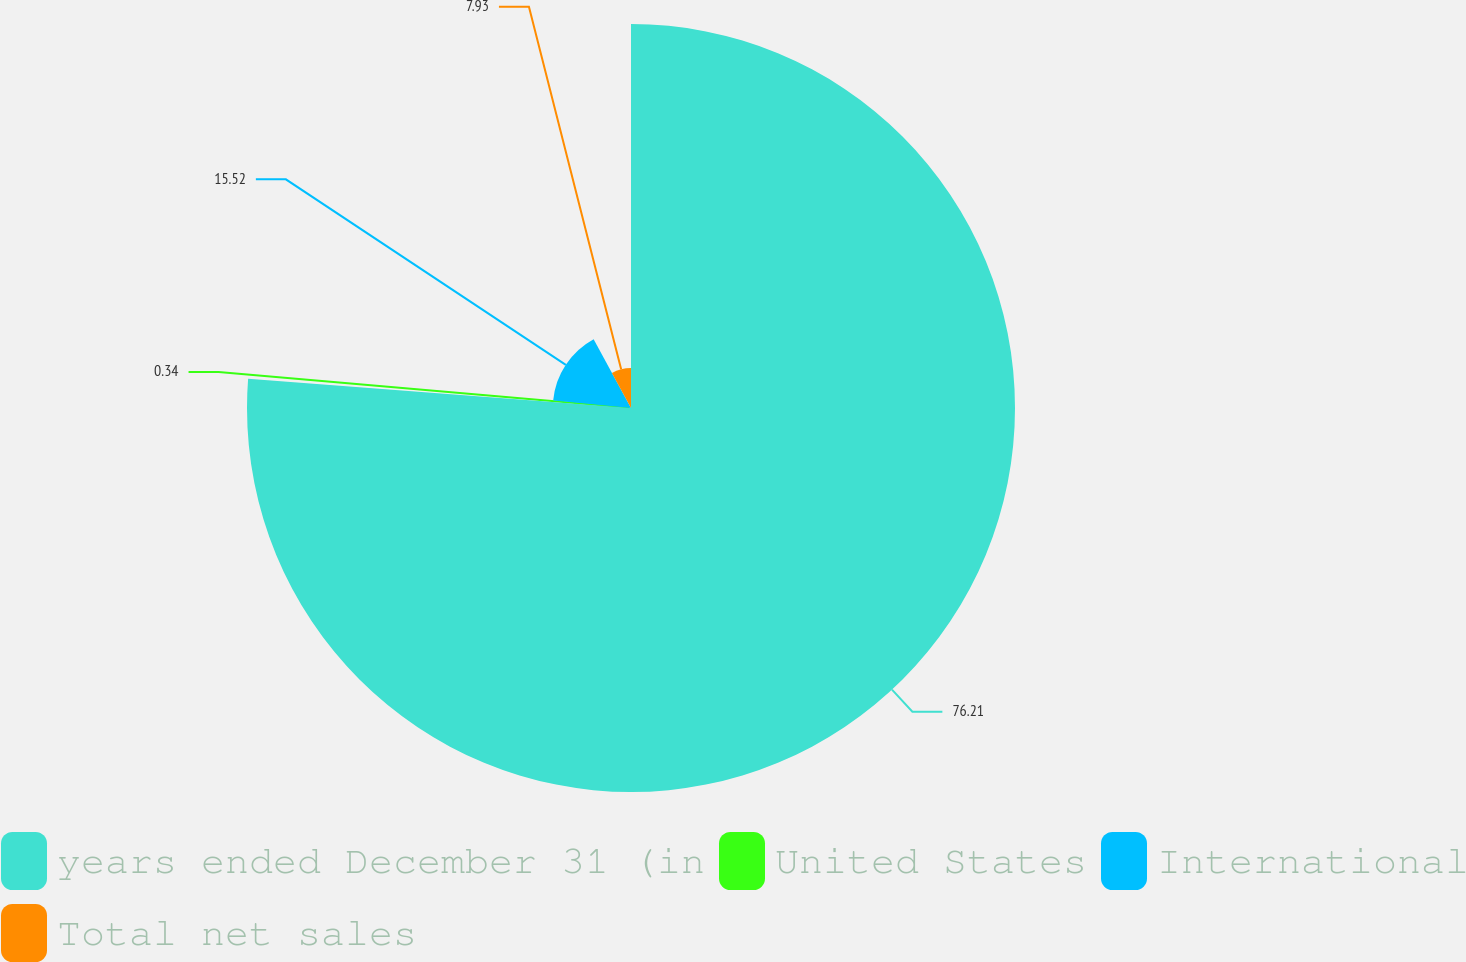Convert chart. <chart><loc_0><loc_0><loc_500><loc_500><pie_chart><fcel>years ended December 31 (in<fcel>United States<fcel>International<fcel>Total net sales<nl><fcel>76.22%<fcel>0.34%<fcel>15.52%<fcel>7.93%<nl></chart> 